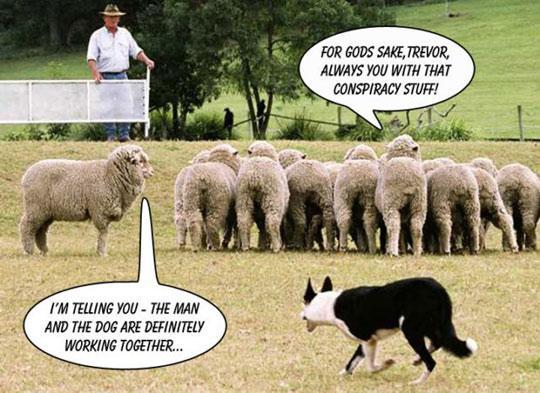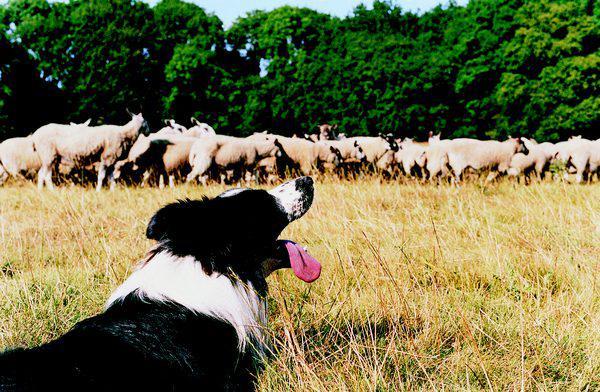The first image is the image on the left, the second image is the image on the right. Given the left and right images, does the statement "An image shows a dog at the right herding no more than three sheep, which are at the left." hold true? Answer yes or no. No. 